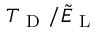Convert formula to latex. <formula><loc_0><loc_0><loc_500><loc_500>T _ { D } / \tilde { E } _ { L }</formula> 